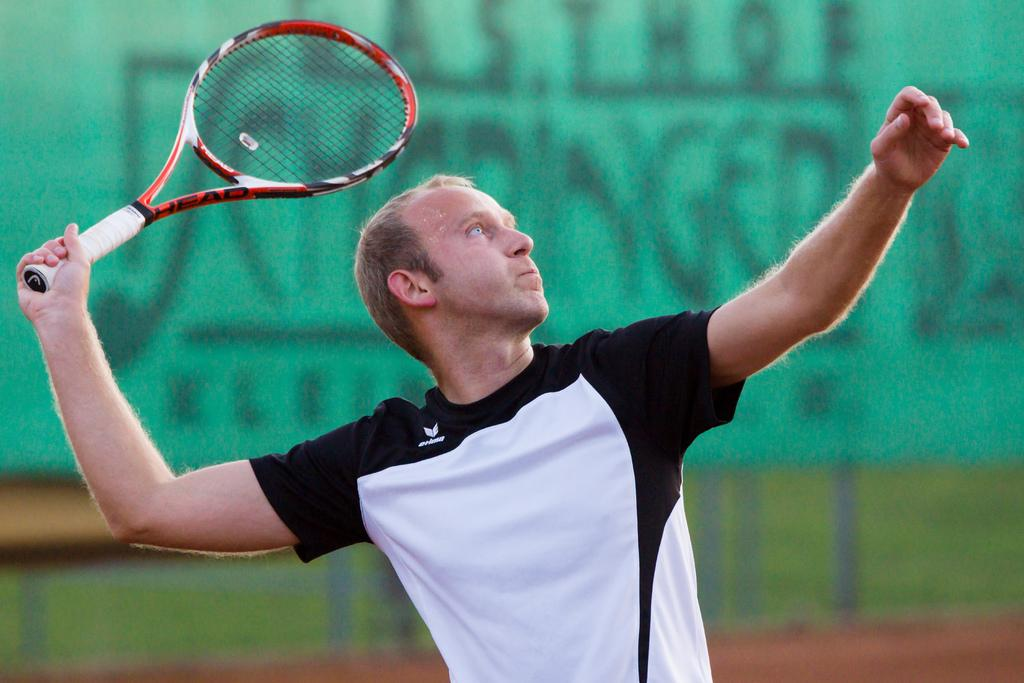Who or what is the main subject in the image? There is a person in the image. What is the person wearing? The person is wearing a black and white t-shirt. What object is the person holding? The person is holding a tennis racket. Can you describe the background of the image? The background of the image is blurred. Are there any fairies visible in the image? No, there are no fairies present in the image. What force is being applied to the tennis racket in the image? The image does not show any force being applied to the tennis racket; it is simply being held by the person. 